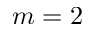Convert formula to latex. <formula><loc_0><loc_0><loc_500><loc_500>m = 2</formula> 